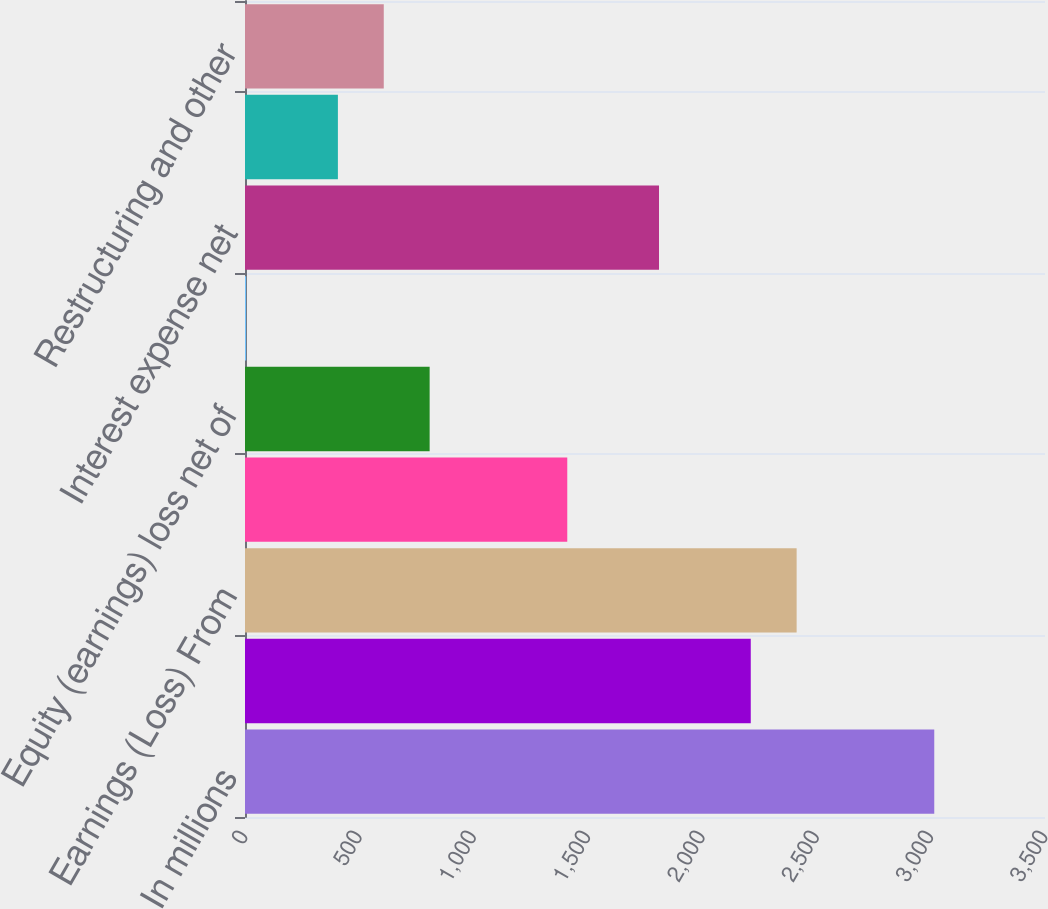Convert chart to OTSL. <chart><loc_0><loc_0><loc_500><loc_500><bar_chart><fcel>In millions<fcel>Net Earnings (Loss)<fcel>Earnings (Loss) From<fcel>Income tax provision<fcel>Equity (earnings) loss net of<fcel>Net earnings attributable to<fcel>Interest expense net<fcel>Corporate items<fcel>Restructuring and other<nl><fcel>3015.5<fcel>2212.7<fcel>2413.4<fcel>1409.9<fcel>807.8<fcel>5<fcel>1811.3<fcel>406.4<fcel>607.1<nl></chart> 